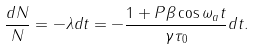<formula> <loc_0><loc_0><loc_500><loc_500>\frac { d N } { N } = - \lambda d t = - \frac { 1 + P \beta \cos \omega _ { a } t } { \gamma \tau _ { 0 } } d t .</formula> 